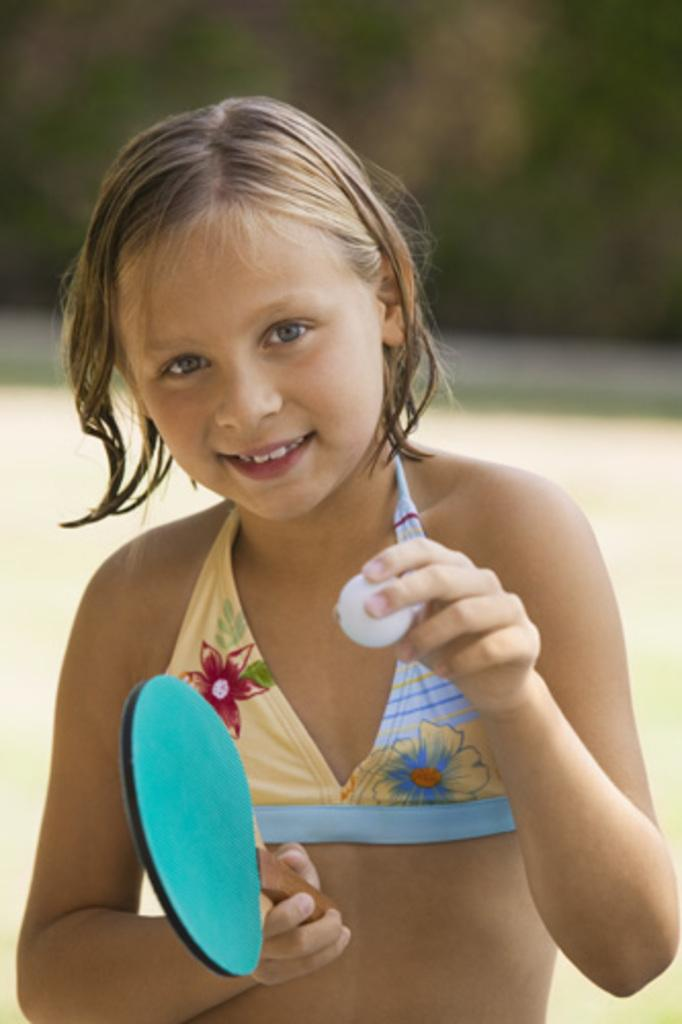Who is the main subject in the image? There is a girl in the image. What is the girl holding in one hand? The girl is holding a tennis bat in one hand. What is the girl holding in the other hand? The girl is holding a ball in the other hand. What type of account does the girl have with the shop in the image? There is no shop or account mentioned in the image; it only features a girl holding a tennis bat and a ball. 